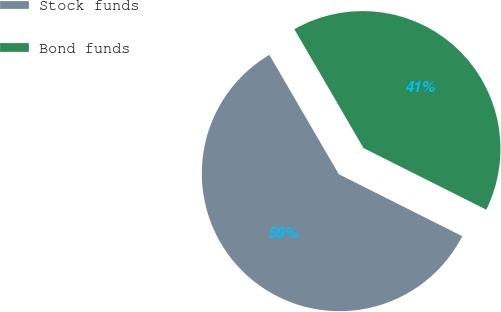Convert chart to OTSL. <chart><loc_0><loc_0><loc_500><loc_500><pie_chart><fcel>Stock funds<fcel>Bond funds<nl><fcel>59.21%<fcel>40.79%<nl></chart> 